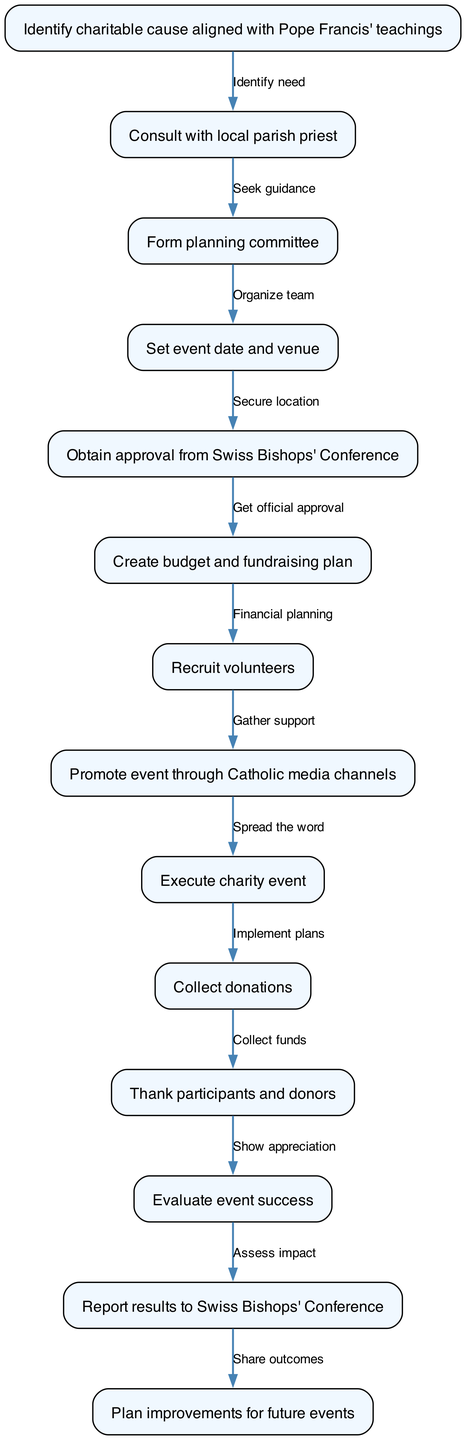What is the first step in planning the event? The flow chart starts with "Identify charitable cause aligned with Pope Francis' teachings" as the first node.
Answer: Identify charitable cause aligned with Pope Francis' teachings How many nodes are there in the diagram? The diagram lists a total of 13 nodes, which represent the different steps in the process of planning and executing the charity event.
Answer: 13 What is the last step mentioned in the flow chart? The final node in the flow chart is "Plan improvements for future events," indicating that reflections on past events lead to future enhancements.
Answer: Plan improvements for future events Which step follows "Create budget and fundraising plan"? In the flow of the diagram, "Recruit volunteers" directly follows "Create budget and fundraising plan," indicating the next step in the process.
Answer: Recruit volunteers Which step requires obtaining approval? The step that involves seeking formal approval is "Obtain approval from Swiss Bishops' Conference," as this is a necessary prerequisite before proceeding with the event.
Answer: Obtain approval from Swiss Bishops' Conference How many edges connect the nodes? There are 12 edges in the diagram, linking the 13 nodes and representing the relationships and flow of steps.
Answer: 12 What is the relationship between "Thank participants and donors" and "Evaluate event success"? According to the flow, "Thank participants and donors" occurs before "Evaluate event success," indicating that appreciation is extended prior to assessment.
Answer: Thank participants and donors Which step is related to community engagement? "Promote event through Catholic media channels" is directly focused on engaging the community and raising awareness about the event.
Answer: Promote event through Catholic media channels What is the step that comes after "Execute charity event"? Following "Execute charity event," the next step in the flow is "Collect donations," demonstrating the transition from event execution to donation collection.
Answer: Collect donations 